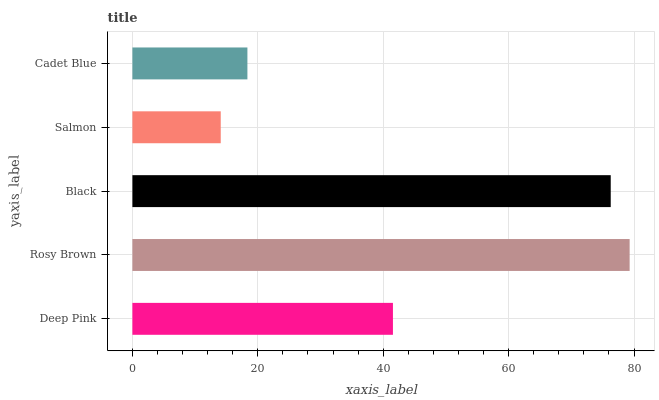Is Salmon the minimum?
Answer yes or no. Yes. Is Rosy Brown the maximum?
Answer yes or no. Yes. Is Black the minimum?
Answer yes or no. No. Is Black the maximum?
Answer yes or no. No. Is Rosy Brown greater than Black?
Answer yes or no. Yes. Is Black less than Rosy Brown?
Answer yes or no. Yes. Is Black greater than Rosy Brown?
Answer yes or no. No. Is Rosy Brown less than Black?
Answer yes or no. No. Is Deep Pink the high median?
Answer yes or no. Yes. Is Deep Pink the low median?
Answer yes or no. Yes. Is Cadet Blue the high median?
Answer yes or no. No. Is Black the low median?
Answer yes or no. No. 